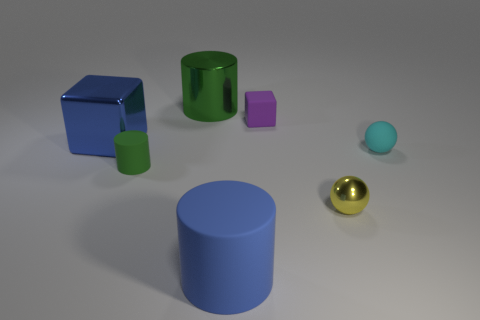What is the material of the big thing that is the same color as the tiny cylinder?
Your answer should be compact. Metal. Do the metallic cylinder and the small cylinder have the same color?
Your answer should be compact. Yes. There is a matte object in front of the tiny green thing; is its color the same as the big block?
Provide a succinct answer. Yes. Are the large blue object that is on the right side of the green rubber cylinder and the small yellow object made of the same material?
Your response must be concise. No. What is the blue block made of?
Give a very brief answer. Metal. Are there any rubber objects in front of the tiny metallic sphere?
Ensure brevity in your answer.  Yes. What is the size of the blue thing that is the same material as the tiny purple block?
Give a very brief answer. Large. How many large metallic things are the same color as the large rubber thing?
Your answer should be compact. 1. Are there fewer matte objects to the left of the small yellow metallic object than objects that are to the left of the cyan sphere?
Your response must be concise. Yes. What is the size of the sphere that is in front of the tiny cylinder?
Keep it short and to the point. Small. 